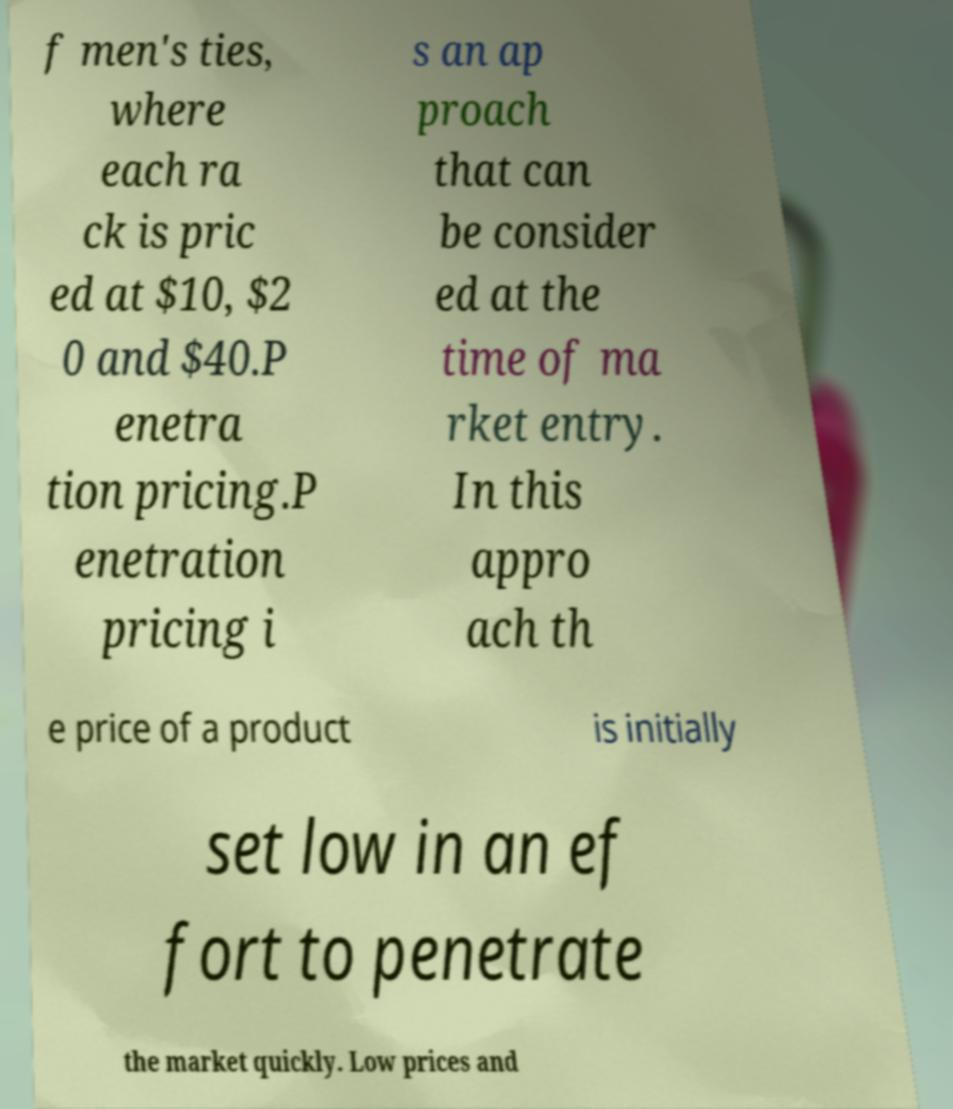Could you extract and type out the text from this image? f men's ties, where each ra ck is pric ed at $10, $2 0 and $40.P enetra tion pricing.P enetration pricing i s an ap proach that can be consider ed at the time of ma rket entry. In this appro ach th e price of a product is initially set low in an ef fort to penetrate the market quickly. Low prices and 